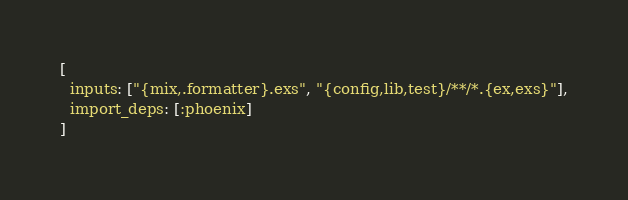Convert code to text. <code><loc_0><loc_0><loc_500><loc_500><_Elixir_>[
  inputs: ["{mix,.formatter}.exs", "{config,lib,test}/**/*.{ex,exs}"],
  import_deps: [:phoenix]
]
</code> 